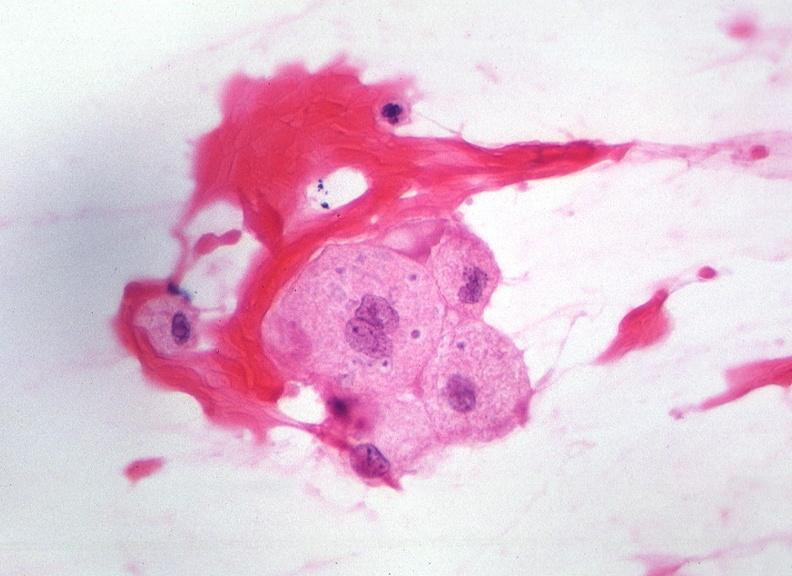does linear fracture in occiput show touch impression from cerebrospinal fluid - toxoplasma?
Answer the question using a single word or phrase. No 